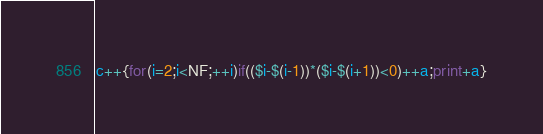<code> <loc_0><loc_0><loc_500><loc_500><_Awk_>c++{for(i=2;i<NF;++i)if(($i-$(i-1))*($i-$(i+1))<0)++a;print+a}</code> 